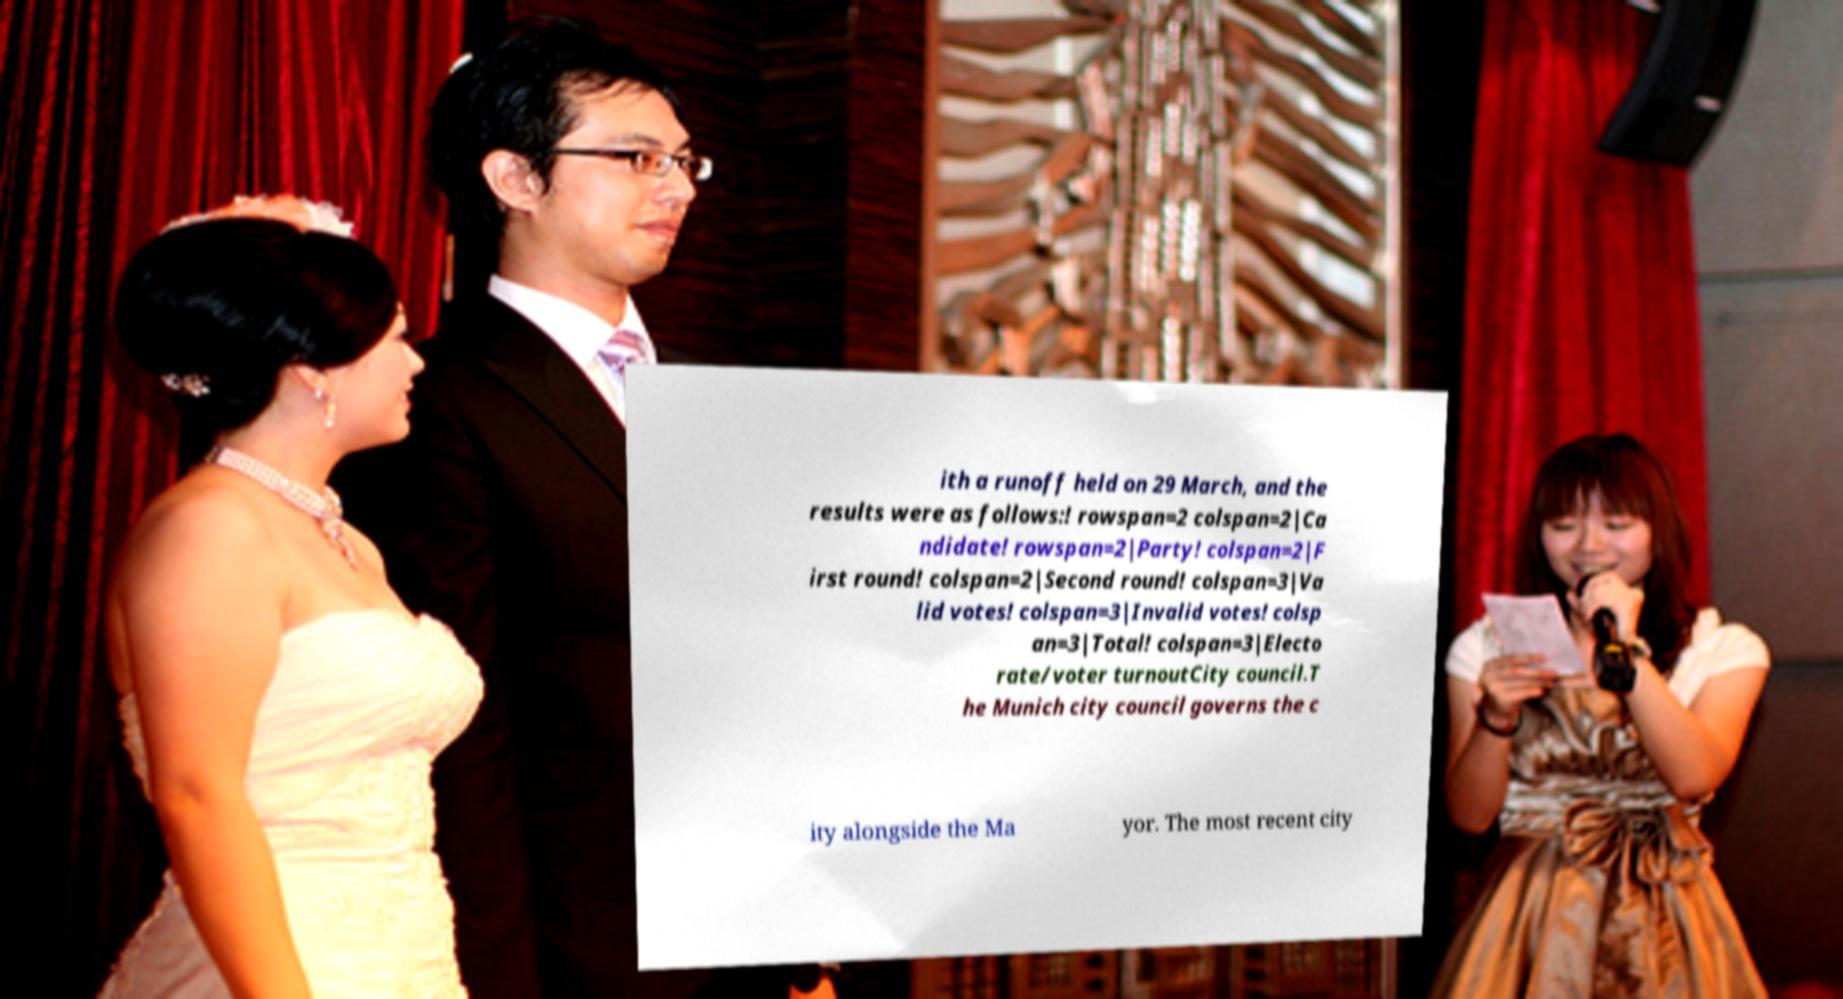For documentation purposes, I need the text within this image transcribed. Could you provide that? ith a runoff held on 29 March, and the results were as follows:! rowspan=2 colspan=2|Ca ndidate! rowspan=2|Party! colspan=2|F irst round! colspan=2|Second round! colspan=3|Va lid votes! colspan=3|Invalid votes! colsp an=3|Total! colspan=3|Electo rate/voter turnoutCity council.T he Munich city council governs the c ity alongside the Ma yor. The most recent city 